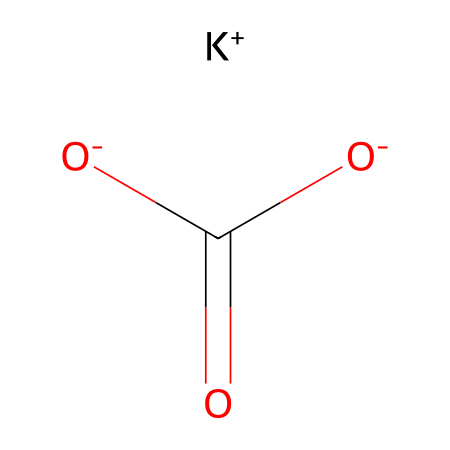What is the chemical name of the compound represented? Based on the SMILES structure, the compound consists of potassium, bicarbonate, and two oxygen atoms, leading to the name potassium bicarbonate.
Answer: potassium bicarbonate How many oxygen atoms are present in the structure? The SMILES representation shows two oxygen atoms bonded to the carbon atom, indicating that there are two oxygen atoms in total.
Answer: 2 What type of chemical is potassium bicarbonate considered? Potassium bicarbonate is classified as an electrolyte because it disassociates into ions in solution, allowing it to conduct electricity.
Answer: electrolyte What ion is represented by [K+] in the SMILES? The [K+] notation indicates that potassium is present as a positively charged ion (cation), which is crucial for the compound's function as an electrolyte.
Answer: potassium ion How many carbon atoms are in the structure? The structure includes one carbon atom connected to the two oxygen atoms and also bonded to the bicarbonate part, indicating a total of one carbon atom.
Answer: 1 What is the charge on the bicarbonate part of the molecule? The bicarbonate part is represented with two negatively charged oxygen atoms, giving it a net charge of -1, which is characteristic of the bicarbonate ion.
Answer: -1 